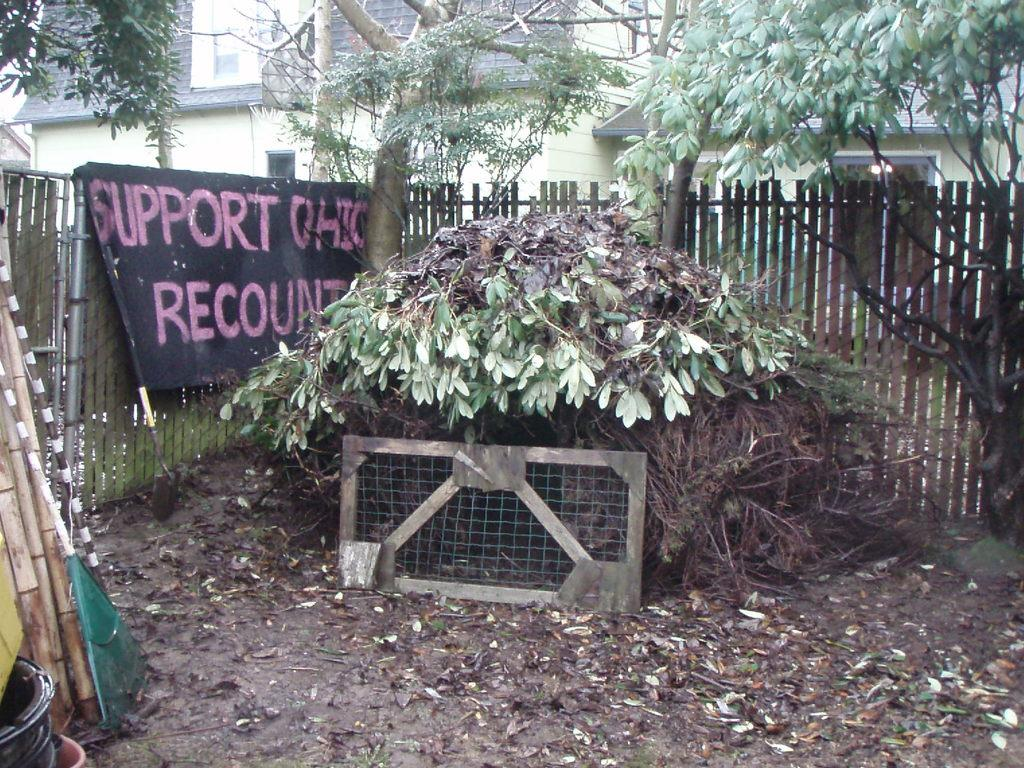What type of vegetation can be seen in the image? There are trees in the image. What is located in the foreground of the image? There is a wooden fence in the foreground of the image. What can be seen on the left side of the image? There is a banner on the left side of the image. What type of structures are visible in the background of the image? There are buildings in the background of the image. How many snails can be seen exchanging mass on the banner in the image? There are no snails present in the image, nor is there any indication of mass exchange. 